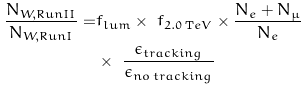<formula> <loc_0><loc_0><loc_500><loc_500>\frac { N _ { W , R u n I I } } { N _ { W , R u n I } } = & f _ { l u m } \times \ f _ { 2 . 0 \, { \mathrm T e V } } \times \frac { N _ { e } + N _ { \mu } } { N _ { e } } \\ & \times \ \frac { \epsilon _ { t r a c k i n g } } { \epsilon _ { n o \, t r a c k i n g } }</formula> 